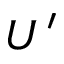Convert formula to latex. <formula><loc_0><loc_0><loc_500><loc_500>U ^ { \prime }</formula> 